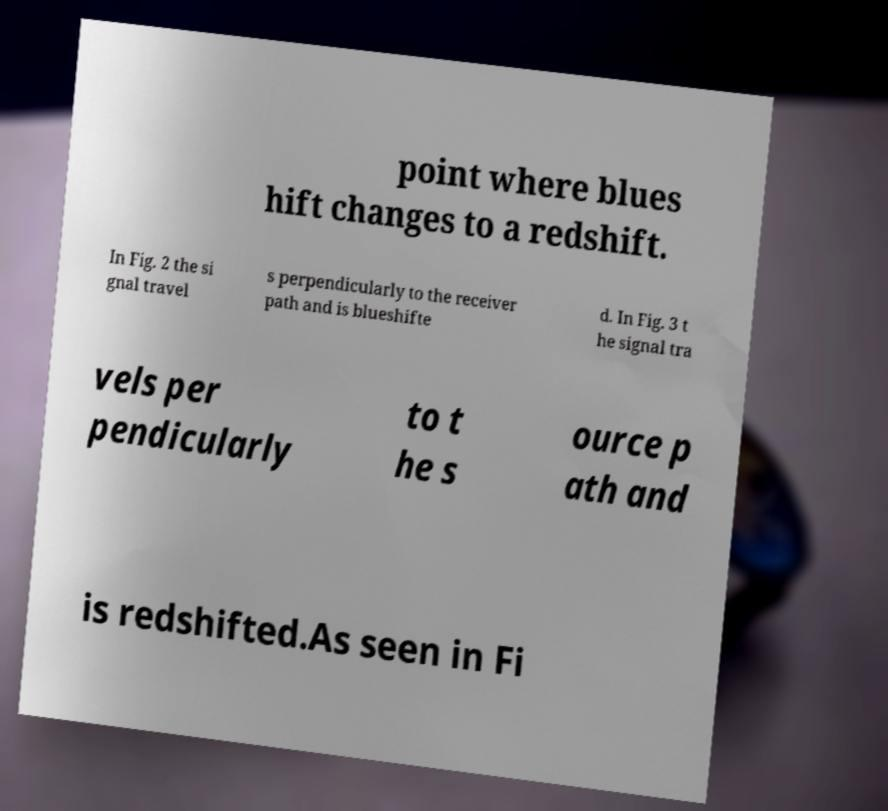Please identify and transcribe the text found in this image. point where blues hift changes to a redshift. In Fig. 2 the si gnal travel s perpendicularly to the receiver path and is blueshifte d. In Fig. 3 t he signal tra vels per pendicularly to t he s ource p ath and is redshifted.As seen in Fi 